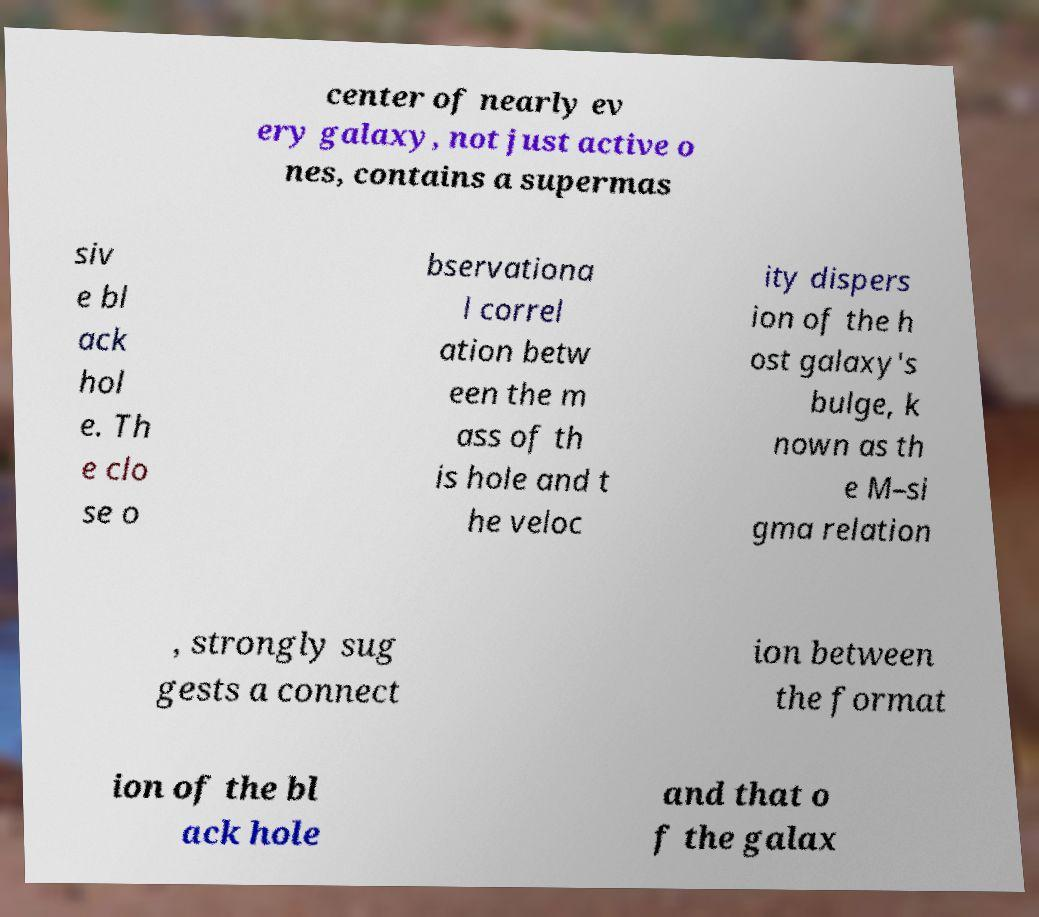Could you extract and type out the text from this image? center of nearly ev ery galaxy, not just active o nes, contains a supermas siv e bl ack hol e. Th e clo se o bservationa l correl ation betw een the m ass of th is hole and t he veloc ity dispers ion of the h ost galaxy's bulge, k nown as th e M–si gma relation , strongly sug gests a connect ion between the format ion of the bl ack hole and that o f the galax 